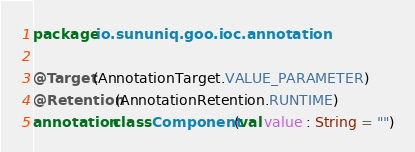<code> <loc_0><loc_0><loc_500><loc_500><_Kotlin_>package io.sununiq.goo.ioc.annotation

@Target(AnnotationTarget.VALUE_PARAMETER)
@Retention(AnnotationRetention.RUNTIME)
annotation class Component(val value : String = "")</code> 